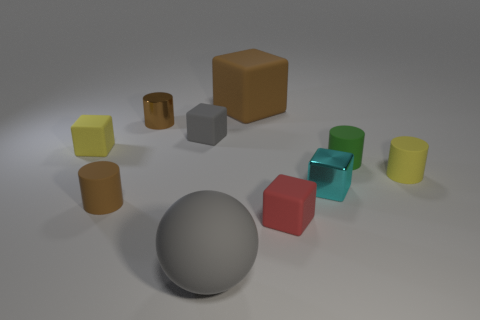Subtract 1 cubes. How many cubes are left? 4 Subtract all yellow cubes. How many cubes are left? 4 Subtract all purple blocks. Subtract all red cylinders. How many blocks are left? 5 Subtract all cylinders. How many objects are left? 6 Subtract all red cubes. Subtract all large rubber things. How many objects are left? 7 Add 4 big brown things. How many big brown things are left? 5 Add 2 blocks. How many blocks exist? 7 Subtract 0 purple cylinders. How many objects are left? 10 